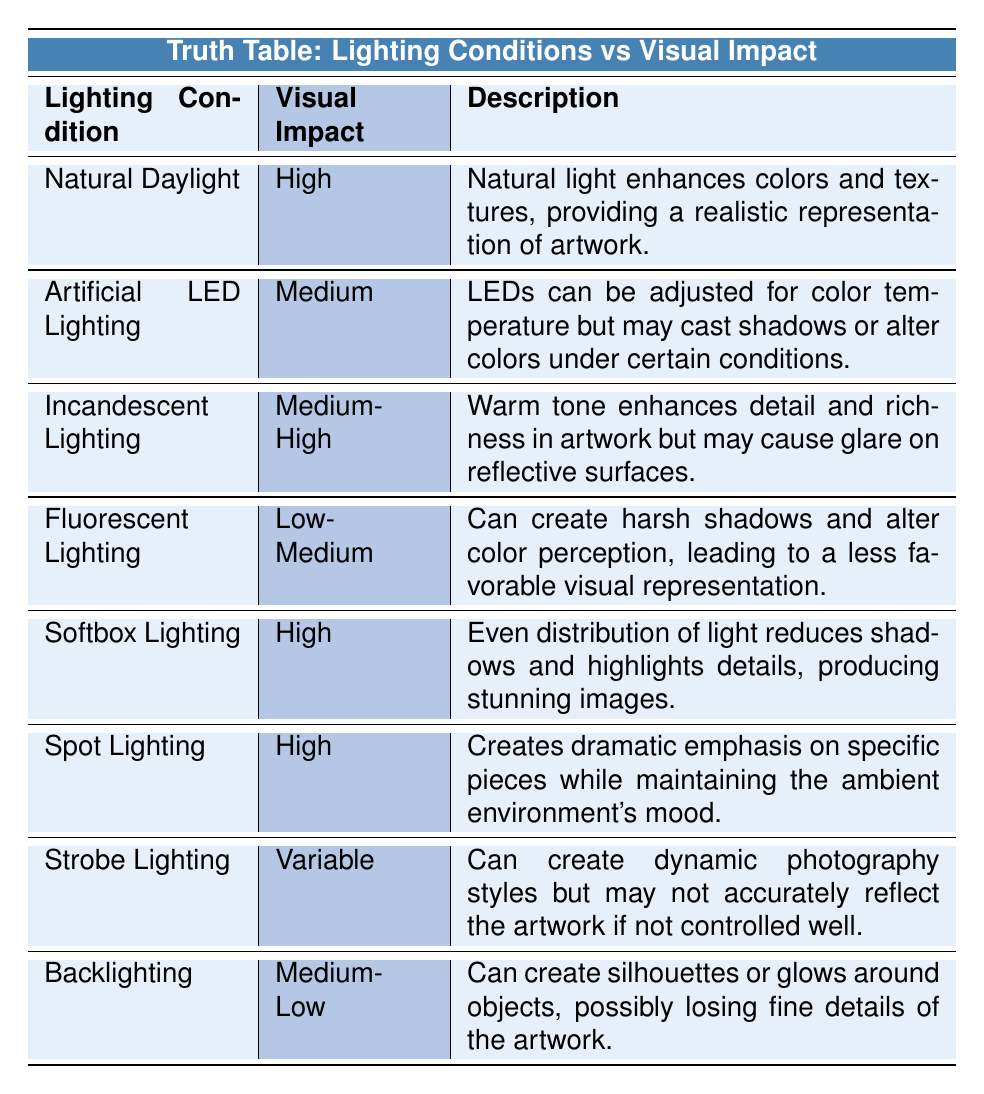What is the visual impact of Natural Daylight? According to the table, the visual impact for Natural Daylight is listed as "High."
Answer: High Which lighting condition has a low-medium visual impact? The table indicates that Fluorescent Lighting has a visual impact rated as "Low-Medium."
Answer: Fluorescent Lighting How many lighting conditions have a high visual impact? By reviewing the table, we see that three conditions—Natural Daylight, Softbox Lighting, and Spot Lighting—are noted with a high visual impact. Therefore, the total count is 3.
Answer: 3 Is Incandescent Lighting more favorable than Artificial LED Lighting in terms of visual impact? The visual impact of Incandescent Lighting is listed as "Medium-High," while Artificial LED Lighting has a rating of "Medium." Since "Medium-High" is greater than "Medium," Incandescent Lighting is indeed more favorable.
Answer: Yes What visual impact rating do Strobe Lighting and Backlighting share? Strobe Lighting has a visual impact categorized as "Variable," and Backlighting is rated "Medium-Low." These ratings do not match, indicating they do not share the same rating.
Answer: No Which lighting condition creates harsh shadows and alters color perception? The description for Fluorescent Lighting states that it can create harsh shadows and alter color perception, suggesting a less favorable visual representation.
Answer: Fluorescent Lighting Considering only the high-impact lighting conditions, what is the overall sentiment about their usability? The high impact ratings indicate that the three lighting options (Natural Daylight, Softbox Lighting, and Spot Lighting) produce favorable outcomes in museum photography. This suggests they are ideally suited for use in such contexts.
Answer: Positive What is the difference in visual impact between Softbox Lighting and Backlighting? Softbox Lighting has a high visual impact, while Backlighting is rated as "Medium-Low." The difference in their rated levels indicates that Softbox Lighting is more effective in terms of visual impact, giving it an advantage of at least one or more categories in favor of Softbox.
Answer: High 